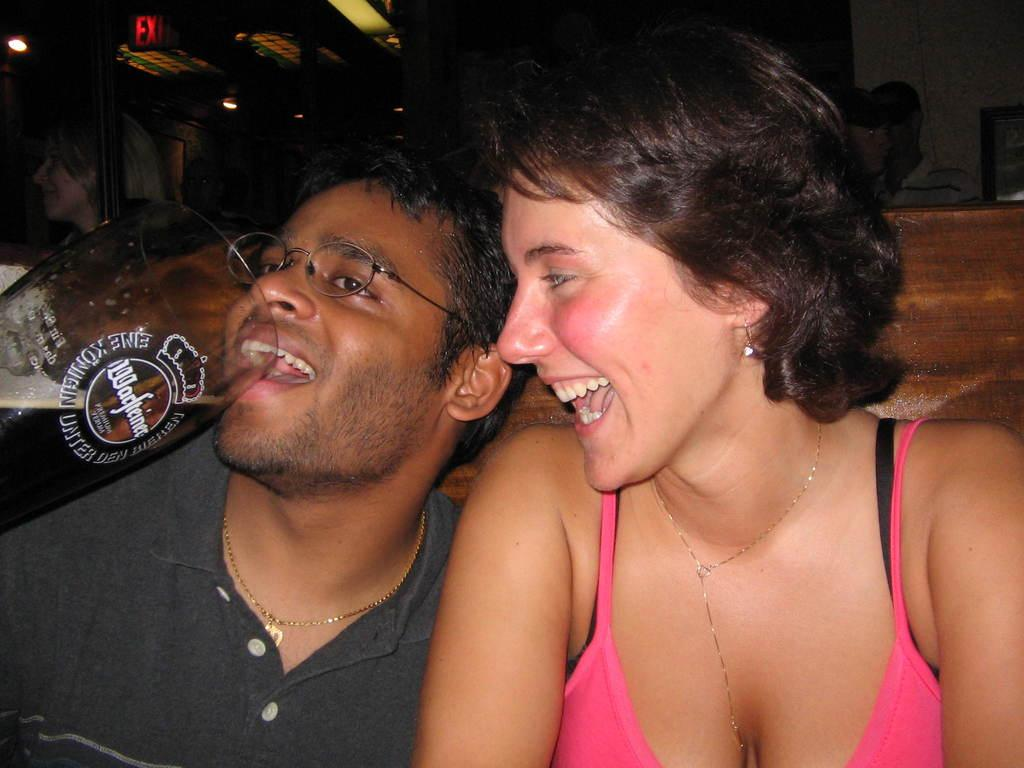What is the woman in the image wearing? The woman is wearing a pink vest. What is the man in the image wearing? The man is wearing a grey t-shirt. What is the man holding in the image? The man is holding a beer. What is the woman's facial expression in the image? The woman is smiling. What can be seen in the background of the image? There is a wooden wall and people standing in the background. What time of day is it in the image, given the presence of a rabbit? There is no rabbit present in the image, so we cannot determine the time of day based on that information. 